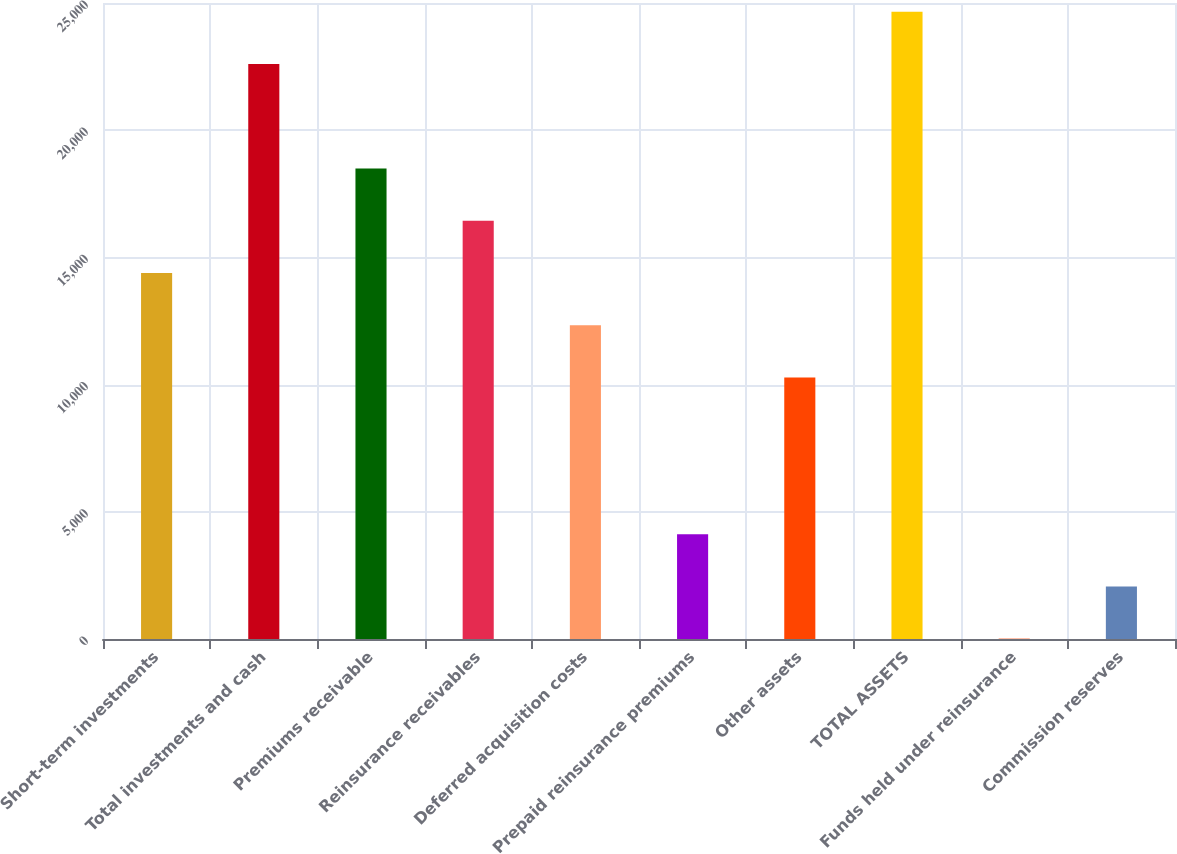Convert chart. <chart><loc_0><loc_0><loc_500><loc_500><bar_chart><fcel>Short-term investments<fcel>Total investments and cash<fcel>Premiums receivable<fcel>Reinsurance receivables<fcel>Deferred acquisition costs<fcel>Prepaid reinsurance premiums<fcel>Other assets<fcel>TOTAL ASSETS<fcel>Funds held under reinsurance<fcel>Commission reserves<nl><fcel>14389.6<fcel>22604.5<fcel>18497.1<fcel>16443.3<fcel>12335.9<fcel>4120.96<fcel>10282.1<fcel>24658.3<fcel>13.5<fcel>2067.23<nl></chart> 